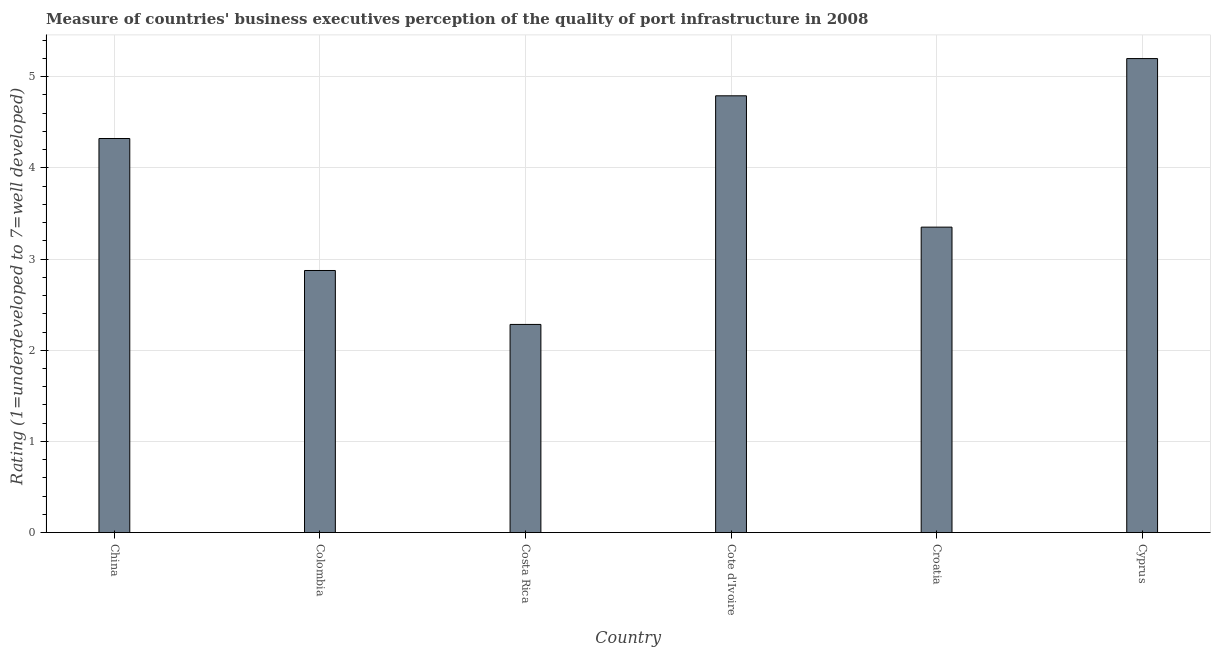Does the graph contain grids?
Make the answer very short. Yes. What is the title of the graph?
Your answer should be compact. Measure of countries' business executives perception of the quality of port infrastructure in 2008. What is the label or title of the Y-axis?
Offer a terse response. Rating (1=underdeveloped to 7=well developed) . What is the rating measuring quality of port infrastructure in Cyprus?
Give a very brief answer. 5.2. Across all countries, what is the maximum rating measuring quality of port infrastructure?
Provide a short and direct response. 5.2. Across all countries, what is the minimum rating measuring quality of port infrastructure?
Your response must be concise. 2.28. In which country was the rating measuring quality of port infrastructure maximum?
Provide a succinct answer. Cyprus. What is the sum of the rating measuring quality of port infrastructure?
Offer a terse response. 22.82. What is the average rating measuring quality of port infrastructure per country?
Give a very brief answer. 3.8. What is the median rating measuring quality of port infrastructure?
Provide a succinct answer. 3.84. What is the ratio of the rating measuring quality of port infrastructure in Croatia to that in Cyprus?
Offer a terse response. 0.64. Is the rating measuring quality of port infrastructure in Colombia less than that in Croatia?
Ensure brevity in your answer.  Yes. Is the difference between the rating measuring quality of port infrastructure in China and Colombia greater than the difference between any two countries?
Give a very brief answer. No. What is the difference between the highest and the second highest rating measuring quality of port infrastructure?
Your response must be concise. 0.41. Is the sum of the rating measuring quality of port infrastructure in Costa Rica and Croatia greater than the maximum rating measuring quality of port infrastructure across all countries?
Keep it short and to the point. Yes. What is the difference between the highest and the lowest rating measuring quality of port infrastructure?
Offer a terse response. 2.92. How many bars are there?
Your answer should be compact. 6. Are all the bars in the graph horizontal?
Ensure brevity in your answer.  No. How many countries are there in the graph?
Your response must be concise. 6. Are the values on the major ticks of Y-axis written in scientific E-notation?
Make the answer very short. No. What is the Rating (1=underdeveloped to 7=well developed)  in China?
Your answer should be very brief. 4.32. What is the Rating (1=underdeveloped to 7=well developed)  of Colombia?
Offer a very short reply. 2.87. What is the Rating (1=underdeveloped to 7=well developed)  in Costa Rica?
Provide a short and direct response. 2.28. What is the Rating (1=underdeveloped to 7=well developed)  in Cote d'Ivoire?
Make the answer very short. 4.79. What is the Rating (1=underdeveloped to 7=well developed)  of Croatia?
Your response must be concise. 3.35. What is the Rating (1=underdeveloped to 7=well developed)  in Cyprus?
Make the answer very short. 5.2. What is the difference between the Rating (1=underdeveloped to 7=well developed)  in China and Colombia?
Give a very brief answer. 1.45. What is the difference between the Rating (1=underdeveloped to 7=well developed)  in China and Costa Rica?
Your response must be concise. 2.04. What is the difference between the Rating (1=underdeveloped to 7=well developed)  in China and Cote d'Ivoire?
Offer a terse response. -0.47. What is the difference between the Rating (1=underdeveloped to 7=well developed)  in China and Croatia?
Provide a succinct answer. 0.97. What is the difference between the Rating (1=underdeveloped to 7=well developed)  in China and Cyprus?
Your response must be concise. -0.88. What is the difference between the Rating (1=underdeveloped to 7=well developed)  in Colombia and Costa Rica?
Provide a short and direct response. 0.59. What is the difference between the Rating (1=underdeveloped to 7=well developed)  in Colombia and Cote d'Ivoire?
Offer a very short reply. -1.92. What is the difference between the Rating (1=underdeveloped to 7=well developed)  in Colombia and Croatia?
Provide a succinct answer. -0.48. What is the difference between the Rating (1=underdeveloped to 7=well developed)  in Colombia and Cyprus?
Your answer should be compact. -2.32. What is the difference between the Rating (1=underdeveloped to 7=well developed)  in Costa Rica and Cote d'Ivoire?
Make the answer very short. -2.51. What is the difference between the Rating (1=underdeveloped to 7=well developed)  in Costa Rica and Croatia?
Your answer should be compact. -1.07. What is the difference between the Rating (1=underdeveloped to 7=well developed)  in Costa Rica and Cyprus?
Your answer should be compact. -2.92. What is the difference between the Rating (1=underdeveloped to 7=well developed)  in Cote d'Ivoire and Croatia?
Keep it short and to the point. 1.44. What is the difference between the Rating (1=underdeveloped to 7=well developed)  in Cote d'Ivoire and Cyprus?
Make the answer very short. -0.41. What is the difference between the Rating (1=underdeveloped to 7=well developed)  in Croatia and Cyprus?
Your response must be concise. -1.85. What is the ratio of the Rating (1=underdeveloped to 7=well developed)  in China to that in Colombia?
Your answer should be very brief. 1.5. What is the ratio of the Rating (1=underdeveloped to 7=well developed)  in China to that in Costa Rica?
Make the answer very short. 1.89. What is the ratio of the Rating (1=underdeveloped to 7=well developed)  in China to that in Cote d'Ivoire?
Make the answer very short. 0.9. What is the ratio of the Rating (1=underdeveloped to 7=well developed)  in China to that in Croatia?
Provide a short and direct response. 1.29. What is the ratio of the Rating (1=underdeveloped to 7=well developed)  in China to that in Cyprus?
Keep it short and to the point. 0.83. What is the ratio of the Rating (1=underdeveloped to 7=well developed)  in Colombia to that in Costa Rica?
Your answer should be compact. 1.26. What is the ratio of the Rating (1=underdeveloped to 7=well developed)  in Colombia to that in Cote d'Ivoire?
Your answer should be compact. 0.6. What is the ratio of the Rating (1=underdeveloped to 7=well developed)  in Colombia to that in Croatia?
Your response must be concise. 0.86. What is the ratio of the Rating (1=underdeveloped to 7=well developed)  in Colombia to that in Cyprus?
Offer a terse response. 0.55. What is the ratio of the Rating (1=underdeveloped to 7=well developed)  in Costa Rica to that in Cote d'Ivoire?
Keep it short and to the point. 0.48. What is the ratio of the Rating (1=underdeveloped to 7=well developed)  in Costa Rica to that in Croatia?
Offer a very short reply. 0.68. What is the ratio of the Rating (1=underdeveloped to 7=well developed)  in Costa Rica to that in Cyprus?
Your answer should be compact. 0.44. What is the ratio of the Rating (1=underdeveloped to 7=well developed)  in Cote d'Ivoire to that in Croatia?
Give a very brief answer. 1.43. What is the ratio of the Rating (1=underdeveloped to 7=well developed)  in Cote d'Ivoire to that in Cyprus?
Offer a terse response. 0.92. What is the ratio of the Rating (1=underdeveloped to 7=well developed)  in Croatia to that in Cyprus?
Offer a very short reply. 0.64. 